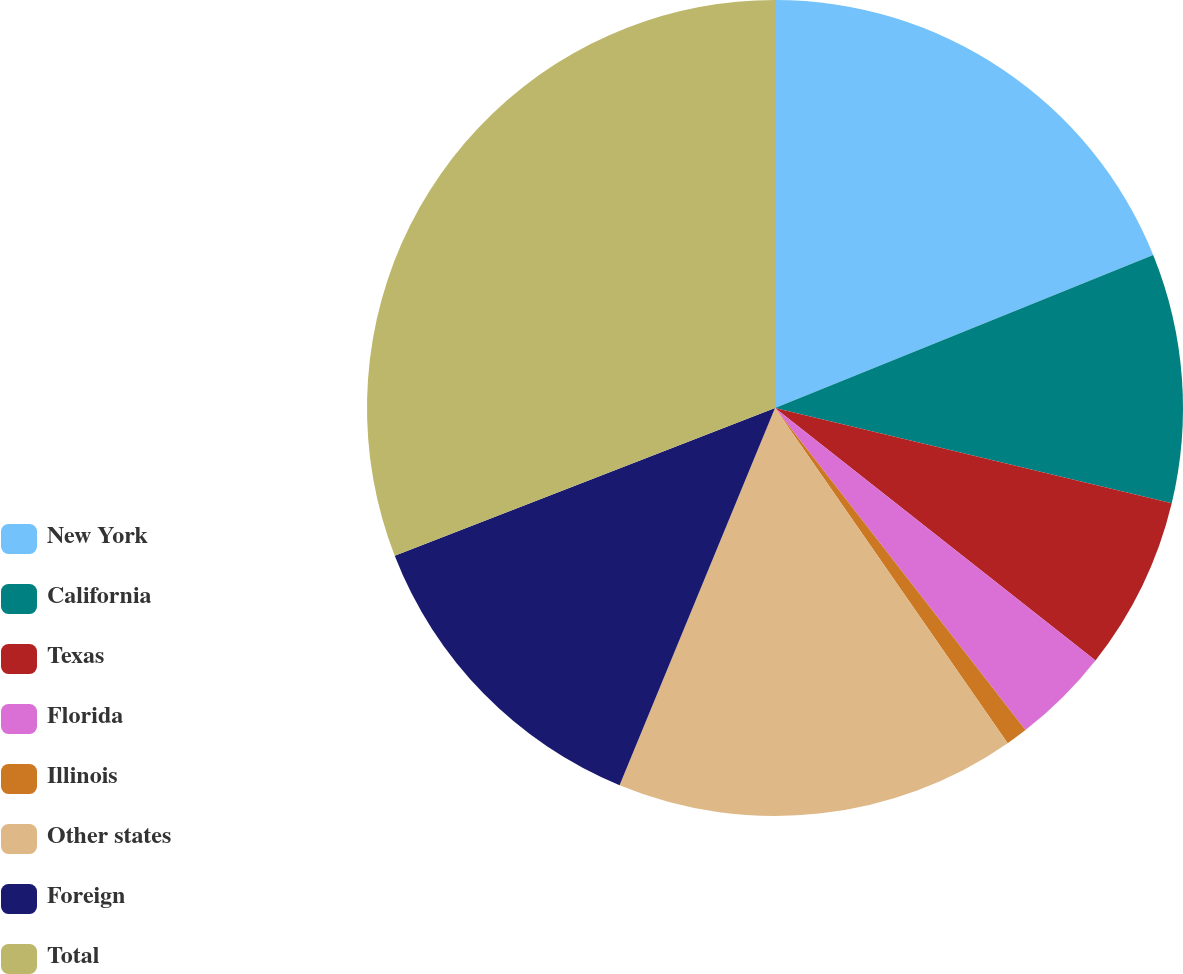Convert chart. <chart><loc_0><loc_0><loc_500><loc_500><pie_chart><fcel>New York<fcel>California<fcel>Texas<fcel>Florida<fcel>Illinois<fcel>Other states<fcel>Foreign<fcel>Total<nl><fcel>18.88%<fcel>9.87%<fcel>6.87%<fcel>3.86%<fcel>0.86%<fcel>15.88%<fcel>12.88%<fcel>30.9%<nl></chart> 